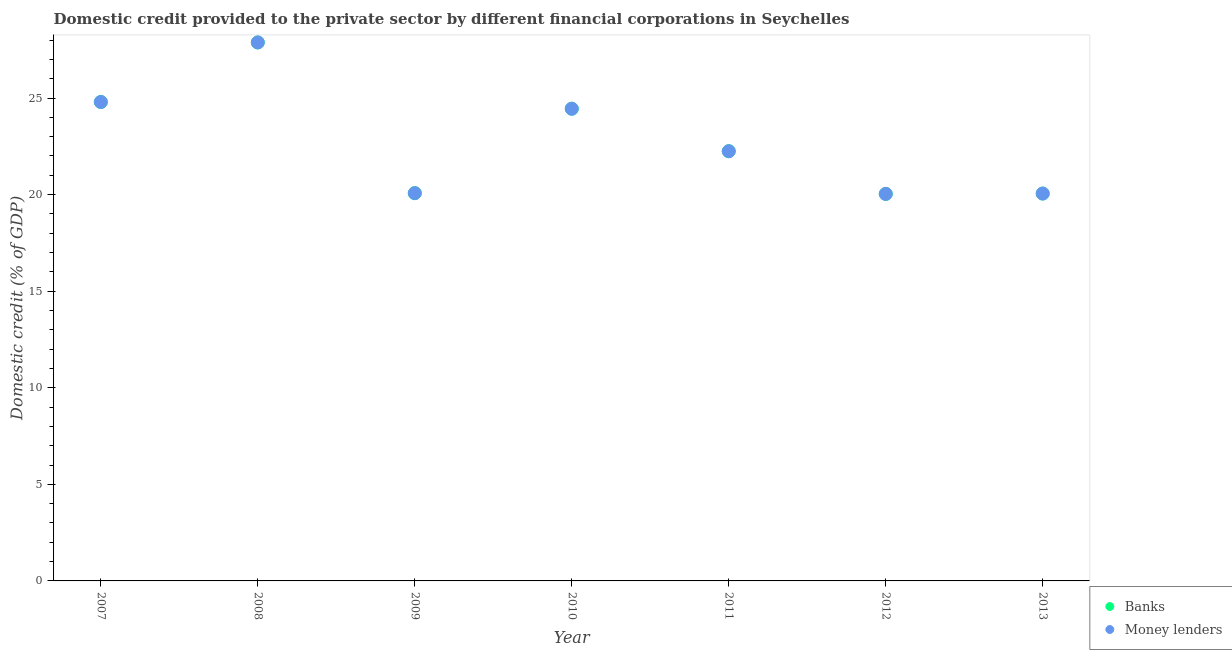How many different coloured dotlines are there?
Your response must be concise. 2. Is the number of dotlines equal to the number of legend labels?
Offer a very short reply. Yes. What is the domestic credit provided by banks in 2013?
Provide a short and direct response. 20.05. Across all years, what is the maximum domestic credit provided by money lenders?
Keep it short and to the point. 27.88. Across all years, what is the minimum domestic credit provided by money lenders?
Your answer should be very brief. 20.04. In which year was the domestic credit provided by banks minimum?
Your answer should be very brief. 2012. What is the total domestic credit provided by banks in the graph?
Provide a succinct answer. 159.53. What is the difference between the domestic credit provided by money lenders in 2009 and that in 2011?
Make the answer very short. -2.17. What is the difference between the domestic credit provided by money lenders in 2011 and the domestic credit provided by banks in 2013?
Provide a short and direct response. 2.19. What is the average domestic credit provided by money lenders per year?
Keep it short and to the point. 22.79. In how many years, is the domestic credit provided by banks greater than 6 %?
Keep it short and to the point. 7. What is the ratio of the domestic credit provided by banks in 2007 to that in 2012?
Your answer should be compact. 1.24. Is the difference between the domestic credit provided by banks in 2010 and 2011 greater than the difference between the domestic credit provided by money lenders in 2010 and 2011?
Provide a succinct answer. No. What is the difference between the highest and the second highest domestic credit provided by banks?
Offer a terse response. 3.08. What is the difference between the highest and the lowest domestic credit provided by banks?
Provide a succinct answer. 7.84. Is the sum of the domestic credit provided by money lenders in 2007 and 2011 greater than the maximum domestic credit provided by banks across all years?
Make the answer very short. Yes. Does the domestic credit provided by banks monotonically increase over the years?
Keep it short and to the point. No. Is the domestic credit provided by money lenders strictly greater than the domestic credit provided by banks over the years?
Offer a very short reply. No. Is the domestic credit provided by money lenders strictly less than the domestic credit provided by banks over the years?
Make the answer very short. No. How many dotlines are there?
Your response must be concise. 2. Does the graph contain any zero values?
Your answer should be very brief. No. Where does the legend appear in the graph?
Keep it short and to the point. Bottom right. How many legend labels are there?
Ensure brevity in your answer.  2. How are the legend labels stacked?
Your answer should be very brief. Vertical. What is the title of the graph?
Make the answer very short. Domestic credit provided to the private sector by different financial corporations in Seychelles. Does "RDB nonconcessional" appear as one of the legend labels in the graph?
Offer a terse response. No. What is the label or title of the Y-axis?
Offer a very short reply. Domestic credit (% of GDP). What is the Domestic credit (% of GDP) in Banks in 2007?
Keep it short and to the point. 24.79. What is the Domestic credit (% of GDP) in Money lenders in 2007?
Your answer should be compact. 24.79. What is the Domestic credit (% of GDP) in Banks in 2008?
Provide a succinct answer. 27.88. What is the Domestic credit (% of GDP) of Money lenders in 2008?
Provide a succinct answer. 27.88. What is the Domestic credit (% of GDP) of Banks in 2009?
Your response must be concise. 20.07. What is the Domestic credit (% of GDP) in Money lenders in 2009?
Keep it short and to the point. 20.07. What is the Domestic credit (% of GDP) in Banks in 2010?
Offer a very short reply. 24.45. What is the Domestic credit (% of GDP) of Money lenders in 2010?
Provide a succinct answer. 24.45. What is the Domestic credit (% of GDP) of Banks in 2011?
Offer a very short reply. 22.25. What is the Domestic credit (% of GDP) of Money lenders in 2011?
Offer a terse response. 22.25. What is the Domestic credit (% of GDP) of Banks in 2012?
Your response must be concise. 20.04. What is the Domestic credit (% of GDP) of Money lenders in 2012?
Give a very brief answer. 20.04. What is the Domestic credit (% of GDP) in Banks in 2013?
Your response must be concise. 20.05. What is the Domestic credit (% of GDP) of Money lenders in 2013?
Offer a very short reply. 20.05. Across all years, what is the maximum Domestic credit (% of GDP) in Banks?
Keep it short and to the point. 27.88. Across all years, what is the maximum Domestic credit (% of GDP) in Money lenders?
Your response must be concise. 27.88. Across all years, what is the minimum Domestic credit (% of GDP) of Banks?
Offer a terse response. 20.04. Across all years, what is the minimum Domestic credit (% of GDP) of Money lenders?
Offer a terse response. 20.04. What is the total Domestic credit (% of GDP) of Banks in the graph?
Your answer should be very brief. 159.53. What is the total Domestic credit (% of GDP) of Money lenders in the graph?
Keep it short and to the point. 159.53. What is the difference between the Domestic credit (% of GDP) of Banks in 2007 and that in 2008?
Your response must be concise. -3.08. What is the difference between the Domestic credit (% of GDP) in Money lenders in 2007 and that in 2008?
Ensure brevity in your answer.  -3.08. What is the difference between the Domestic credit (% of GDP) in Banks in 2007 and that in 2009?
Give a very brief answer. 4.72. What is the difference between the Domestic credit (% of GDP) of Money lenders in 2007 and that in 2009?
Offer a terse response. 4.72. What is the difference between the Domestic credit (% of GDP) in Banks in 2007 and that in 2010?
Your answer should be compact. 0.35. What is the difference between the Domestic credit (% of GDP) in Money lenders in 2007 and that in 2010?
Provide a short and direct response. 0.35. What is the difference between the Domestic credit (% of GDP) of Banks in 2007 and that in 2011?
Offer a very short reply. 2.55. What is the difference between the Domestic credit (% of GDP) in Money lenders in 2007 and that in 2011?
Your answer should be very brief. 2.55. What is the difference between the Domestic credit (% of GDP) of Banks in 2007 and that in 2012?
Make the answer very short. 4.76. What is the difference between the Domestic credit (% of GDP) in Money lenders in 2007 and that in 2012?
Give a very brief answer. 4.76. What is the difference between the Domestic credit (% of GDP) of Banks in 2007 and that in 2013?
Offer a terse response. 4.74. What is the difference between the Domestic credit (% of GDP) in Money lenders in 2007 and that in 2013?
Make the answer very short. 4.74. What is the difference between the Domestic credit (% of GDP) of Banks in 2008 and that in 2009?
Keep it short and to the point. 7.8. What is the difference between the Domestic credit (% of GDP) in Money lenders in 2008 and that in 2009?
Offer a very short reply. 7.8. What is the difference between the Domestic credit (% of GDP) in Banks in 2008 and that in 2010?
Provide a succinct answer. 3.43. What is the difference between the Domestic credit (% of GDP) of Money lenders in 2008 and that in 2010?
Offer a very short reply. 3.43. What is the difference between the Domestic credit (% of GDP) in Banks in 2008 and that in 2011?
Make the answer very short. 5.63. What is the difference between the Domestic credit (% of GDP) in Money lenders in 2008 and that in 2011?
Give a very brief answer. 5.63. What is the difference between the Domestic credit (% of GDP) of Banks in 2008 and that in 2012?
Keep it short and to the point. 7.84. What is the difference between the Domestic credit (% of GDP) in Money lenders in 2008 and that in 2012?
Provide a short and direct response. 7.84. What is the difference between the Domestic credit (% of GDP) of Banks in 2008 and that in 2013?
Provide a succinct answer. 7.82. What is the difference between the Domestic credit (% of GDP) in Money lenders in 2008 and that in 2013?
Provide a succinct answer. 7.82. What is the difference between the Domestic credit (% of GDP) of Banks in 2009 and that in 2010?
Your answer should be very brief. -4.37. What is the difference between the Domestic credit (% of GDP) of Money lenders in 2009 and that in 2010?
Your answer should be very brief. -4.37. What is the difference between the Domestic credit (% of GDP) in Banks in 2009 and that in 2011?
Keep it short and to the point. -2.17. What is the difference between the Domestic credit (% of GDP) of Money lenders in 2009 and that in 2011?
Ensure brevity in your answer.  -2.17. What is the difference between the Domestic credit (% of GDP) of Banks in 2009 and that in 2012?
Your answer should be very brief. 0.04. What is the difference between the Domestic credit (% of GDP) of Money lenders in 2009 and that in 2012?
Make the answer very short. 0.04. What is the difference between the Domestic credit (% of GDP) of Banks in 2010 and that in 2011?
Your answer should be compact. 2.2. What is the difference between the Domestic credit (% of GDP) of Money lenders in 2010 and that in 2011?
Ensure brevity in your answer.  2.2. What is the difference between the Domestic credit (% of GDP) in Banks in 2010 and that in 2012?
Provide a succinct answer. 4.41. What is the difference between the Domestic credit (% of GDP) of Money lenders in 2010 and that in 2012?
Offer a very short reply. 4.41. What is the difference between the Domestic credit (% of GDP) in Banks in 2010 and that in 2013?
Ensure brevity in your answer.  4.39. What is the difference between the Domestic credit (% of GDP) in Money lenders in 2010 and that in 2013?
Give a very brief answer. 4.39. What is the difference between the Domestic credit (% of GDP) in Banks in 2011 and that in 2012?
Ensure brevity in your answer.  2.21. What is the difference between the Domestic credit (% of GDP) in Money lenders in 2011 and that in 2012?
Give a very brief answer. 2.21. What is the difference between the Domestic credit (% of GDP) in Banks in 2011 and that in 2013?
Your answer should be compact. 2.19. What is the difference between the Domestic credit (% of GDP) in Money lenders in 2011 and that in 2013?
Your response must be concise. 2.19. What is the difference between the Domestic credit (% of GDP) of Banks in 2012 and that in 2013?
Provide a short and direct response. -0.02. What is the difference between the Domestic credit (% of GDP) in Money lenders in 2012 and that in 2013?
Your response must be concise. -0.02. What is the difference between the Domestic credit (% of GDP) of Banks in 2007 and the Domestic credit (% of GDP) of Money lenders in 2008?
Your answer should be compact. -3.08. What is the difference between the Domestic credit (% of GDP) in Banks in 2007 and the Domestic credit (% of GDP) in Money lenders in 2009?
Offer a terse response. 4.72. What is the difference between the Domestic credit (% of GDP) of Banks in 2007 and the Domestic credit (% of GDP) of Money lenders in 2010?
Offer a very short reply. 0.35. What is the difference between the Domestic credit (% of GDP) in Banks in 2007 and the Domestic credit (% of GDP) in Money lenders in 2011?
Make the answer very short. 2.55. What is the difference between the Domestic credit (% of GDP) of Banks in 2007 and the Domestic credit (% of GDP) of Money lenders in 2012?
Offer a very short reply. 4.76. What is the difference between the Domestic credit (% of GDP) of Banks in 2007 and the Domestic credit (% of GDP) of Money lenders in 2013?
Offer a terse response. 4.74. What is the difference between the Domestic credit (% of GDP) of Banks in 2008 and the Domestic credit (% of GDP) of Money lenders in 2009?
Your response must be concise. 7.8. What is the difference between the Domestic credit (% of GDP) in Banks in 2008 and the Domestic credit (% of GDP) in Money lenders in 2010?
Your answer should be very brief. 3.43. What is the difference between the Domestic credit (% of GDP) in Banks in 2008 and the Domestic credit (% of GDP) in Money lenders in 2011?
Your response must be concise. 5.63. What is the difference between the Domestic credit (% of GDP) of Banks in 2008 and the Domestic credit (% of GDP) of Money lenders in 2012?
Give a very brief answer. 7.84. What is the difference between the Domestic credit (% of GDP) of Banks in 2008 and the Domestic credit (% of GDP) of Money lenders in 2013?
Keep it short and to the point. 7.82. What is the difference between the Domestic credit (% of GDP) in Banks in 2009 and the Domestic credit (% of GDP) in Money lenders in 2010?
Offer a terse response. -4.37. What is the difference between the Domestic credit (% of GDP) of Banks in 2009 and the Domestic credit (% of GDP) of Money lenders in 2011?
Your answer should be very brief. -2.17. What is the difference between the Domestic credit (% of GDP) in Banks in 2009 and the Domestic credit (% of GDP) in Money lenders in 2012?
Give a very brief answer. 0.04. What is the difference between the Domestic credit (% of GDP) in Banks in 2009 and the Domestic credit (% of GDP) in Money lenders in 2013?
Offer a terse response. 0.02. What is the difference between the Domestic credit (% of GDP) of Banks in 2010 and the Domestic credit (% of GDP) of Money lenders in 2011?
Give a very brief answer. 2.2. What is the difference between the Domestic credit (% of GDP) in Banks in 2010 and the Domestic credit (% of GDP) in Money lenders in 2012?
Provide a short and direct response. 4.41. What is the difference between the Domestic credit (% of GDP) in Banks in 2010 and the Domestic credit (% of GDP) in Money lenders in 2013?
Your answer should be compact. 4.39. What is the difference between the Domestic credit (% of GDP) in Banks in 2011 and the Domestic credit (% of GDP) in Money lenders in 2012?
Provide a short and direct response. 2.21. What is the difference between the Domestic credit (% of GDP) of Banks in 2011 and the Domestic credit (% of GDP) of Money lenders in 2013?
Your response must be concise. 2.19. What is the difference between the Domestic credit (% of GDP) of Banks in 2012 and the Domestic credit (% of GDP) of Money lenders in 2013?
Your answer should be very brief. -0.02. What is the average Domestic credit (% of GDP) of Banks per year?
Your answer should be compact. 22.79. What is the average Domestic credit (% of GDP) of Money lenders per year?
Provide a succinct answer. 22.79. In the year 2008, what is the difference between the Domestic credit (% of GDP) in Banks and Domestic credit (% of GDP) in Money lenders?
Your answer should be compact. 0. In the year 2012, what is the difference between the Domestic credit (% of GDP) of Banks and Domestic credit (% of GDP) of Money lenders?
Ensure brevity in your answer.  0. What is the ratio of the Domestic credit (% of GDP) in Banks in 2007 to that in 2008?
Your answer should be compact. 0.89. What is the ratio of the Domestic credit (% of GDP) of Money lenders in 2007 to that in 2008?
Ensure brevity in your answer.  0.89. What is the ratio of the Domestic credit (% of GDP) of Banks in 2007 to that in 2009?
Your response must be concise. 1.24. What is the ratio of the Domestic credit (% of GDP) of Money lenders in 2007 to that in 2009?
Offer a very short reply. 1.24. What is the ratio of the Domestic credit (% of GDP) of Banks in 2007 to that in 2010?
Offer a very short reply. 1.01. What is the ratio of the Domestic credit (% of GDP) in Money lenders in 2007 to that in 2010?
Keep it short and to the point. 1.01. What is the ratio of the Domestic credit (% of GDP) in Banks in 2007 to that in 2011?
Give a very brief answer. 1.11. What is the ratio of the Domestic credit (% of GDP) in Money lenders in 2007 to that in 2011?
Offer a terse response. 1.11. What is the ratio of the Domestic credit (% of GDP) in Banks in 2007 to that in 2012?
Offer a very short reply. 1.24. What is the ratio of the Domestic credit (% of GDP) of Money lenders in 2007 to that in 2012?
Your answer should be very brief. 1.24. What is the ratio of the Domestic credit (% of GDP) in Banks in 2007 to that in 2013?
Offer a terse response. 1.24. What is the ratio of the Domestic credit (% of GDP) in Money lenders in 2007 to that in 2013?
Your answer should be very brief. 1.24. What is the ratio of the Domestic credit (% of GDP) in Banks in 2008 to that in 2009?
Provide a short and direct response. 1.39. What is the ratio of the Domestic credit (% of GDP) in Money lenders in 2008 to that in 2009?
Provide a short and direct response. 1.39. What is the ratio of the Domestic credit (% of GDP) in Banks in 2008 to that in 2010?
Your answer should be very brief. 1.14. What is the ratio of the Domestic credit (% of GDP) in Money lenders in 2008 to that in 2010?
Ensure brevity in your answer.  1.14. What is the ratio of the Domestic credit (% of GDP) of Banks in 2008 to that in 2011?
Give a very brief answer. 1.25. What is the ratio of the Domestic credit (% of GDP) of Money lenders in 2008 to that in 2011?
Provide a short and direct response. 1.25. What is the ratio of the Domestic credit (% of GDP) of Banks in 2008 to that in 2012?
Provide a short and direct response. 1.39. What is the ratio of the Domestic credit (% of GDP) of Money lenders in 2008 to that in 2012?
Your answer should be compact. 1.39. What is the ratio of the Domestic credit (% of GDP) of Banks in 2008 to that in 2013?
Your answer should be very brief. 1.39. What is the ratio of the Domestic credit (% of GDP) in Money lenders in 2008 to that in 2013?
Make the answer very short. 1.39. What is the ratio of the Domestic credit (% of GDP) in Banks in 2009 to that in 2010?
Your response must be concise. 0.82. What is the ratio of the Domestic credit (% of GDP) in Money lenders in 2009 to that in 2010?
Provide a succinct answer. 0.82. What is the ratio of the Domestic credit (% of GDP) in Banks in 2009 to that in 2011?
Ensure brevity in your answer.  0.9. What is the ratio of the Domestic credit (% of GDP) of Money lenders in 2009 to that in 2011?
Your answer should be compact. 0.9. What is the ratio of the Domestic credit (% of GDP) in Money lenders in 2009 to that in 2012?
Your response must be concise. 1. What is the ratio of the Domestic credit (% of GDP) of Banks in 2009 to that in 2013?
Ensure brevity in your answer.  1. What is the ratio of the Domestic credit (% of GDP) of Money lenders in 2009 to that in 2013?
Ensure brevity in your answer.  1. What is the ratio of the Domestic credit (% of GDP) of Banks in 2010 to that in 2011?
Offer a very short reply. 1.1. What is the ratio of the Domestic credit (% of GDP) in Money lenders in 2010 to that in 2011?
Your answer should be very brief. 1.1. What is the ratio of the Domestic credit (% of GDP) in Banks in 2010 to that in 2012?
Offer a very short reply. 1.22. What is the ratio of the Domestic credit (% of GDP) in Money lenders in 2010 to that in 2012?
Offer a terse response. 1.22. What is the ratio of the Domestic credit (% of GDP) in Banks in 2010 to that in 2013?
Your response must be concise. 1.22. What is the ratio of the Domestic credit (% of GDP) in Money lenders in 2010 to that in 2013?
Offer a very short reply. 1.22. What is the ratio of the Domestic credit (% of GDP) of Banks in 2011 to that in 2012?
Your answer should be compact. 1.11. What is the ratio of the Domestic credit (% of GDP) in Money lenders in 2011 to that in 2012?
Ensure brevity in your answer.  1.11. What is the ratio of the Domestic credit (% of GDP) of Banks in 2011 to that in 2013?
Your response must be concise. 1.11. What is the ratio of the Domestic credit (% of GDP) of Money lenders in 2011 to that in 2013?
Offer a terse response. 1.11. What is the ratio of the Domestic credit (% of GDP) in Banks in 2012 to that in 2013?
Your answer should be compact. 1. What is the difference between the highest and the second highest Domestic credit (% of GDP) of Banks?
Your answer should be very brief. 3.08. What is the difference between the highest and the second highest Domestic credit (% of GDP) of Money lenders?
Provide a succinct answer. 3.08. What is the difference between the highest and the lowest Domestic credit (% of GDP) in Banks?
Keep it short and to the point. 7.84. What is the difference between the highest and the lowest Domestic credit (% of GDP) of Money lenders?
Provide a succinct answer. 7.84. 